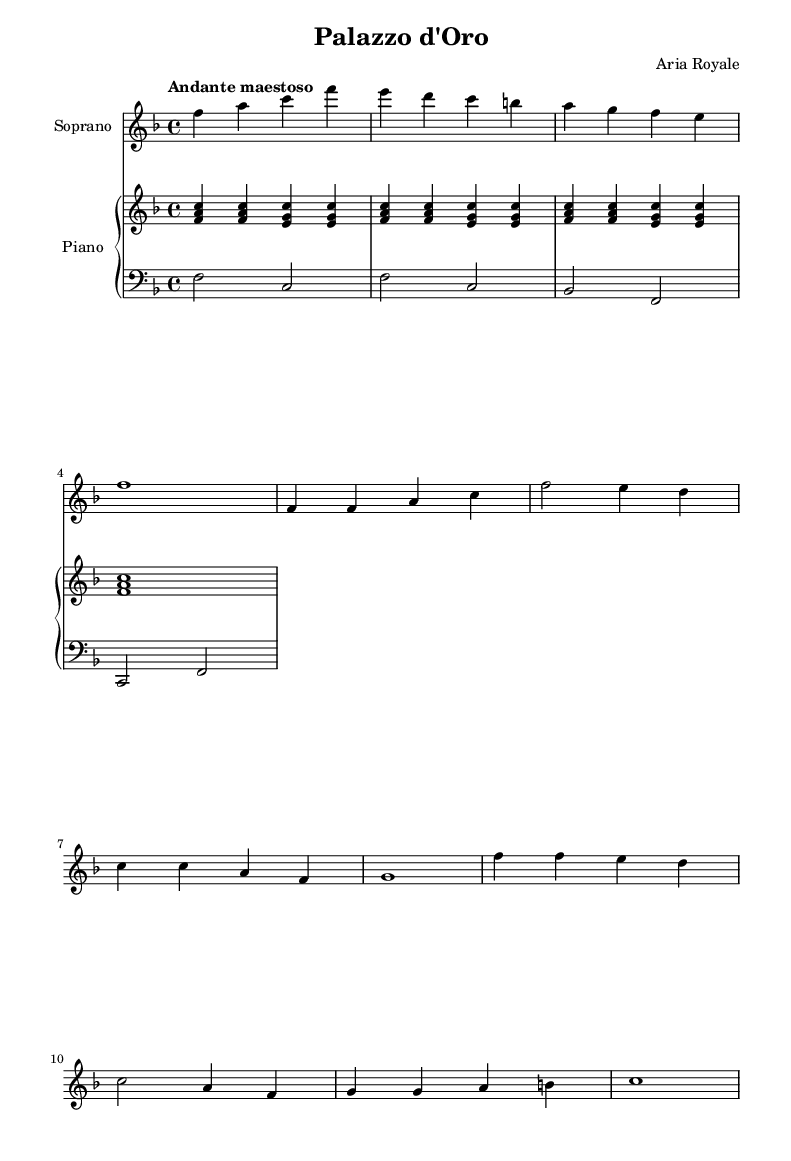What is the key signature of this music? The key signature indicates that the music is in F major, which has one flat (B flat). It can be identified by looking for the flat symbol on the staff at the beginning of the music.
Answer: F major What is the time signature of the piece? The time signature is found in the beginning of the sheet music, where it's marked as 4/4. This means there are four beats in each measure and the quarter note gets one beat.
Answer: 4/4 What tempo marking is indicated? The tempo marking "Andante maestoso" is present at the beginning of the sheet music, closely following the time signature and key signature. "Andante" indicates a moderate pace, and "maestoso" implies a dignified style.
Answer: Andante maestoso How many measures are in the introduction? The introduction consists of four measures, as indicated by the vertical lines separating the music into organized segments. Counting those segments gives a total of four measures.
Answer: 4 What instrument is designated as soprano? The soprano part is explicitly labeled in the score as "Soprano" in the staff title. This indicates that the melodic line should be sung by a soprano voice.
Answer: Soprano What theme does the chorus celebrate? By analyzing the lyrics of the chorus, it is clear that the theme celebrates a grand royal palace, as indicated by the words "Palazzo d'Oro, grand and bright, A vision of opulent delight."
Answer: Grand palace 